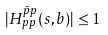<formula> <loc_0><loc_0><loc_500><loc_500>| H _ { p p } ^ { \bar { p } p } ( s , b ) | \leq 1</formula> 